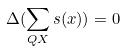<formula> <loc_0><loc_0><loc_500><loc_500>\Delta ( \sum _ { Q X } s ( x ) ) = 0</formula> 